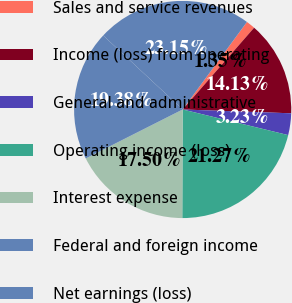Convert chart to OTSL. <chart><loc_0><loc_0><loc_500><loc_500><pie_chart><fcel>Sales and service revenues<fcel>Income (loss) from operating<fcel>General and administrative<fcel>Operating income (loss)<fcel>Interest expense<fcel>Federal and foreign income<fcel>Net earnings (loss)<nl><fcel>1.35%<fcel>14.13%<fcel>3.23%<fcel>21.27%<fcel>17.5%<fcel>19.38%<fcel>23.15%<nl></chart> 